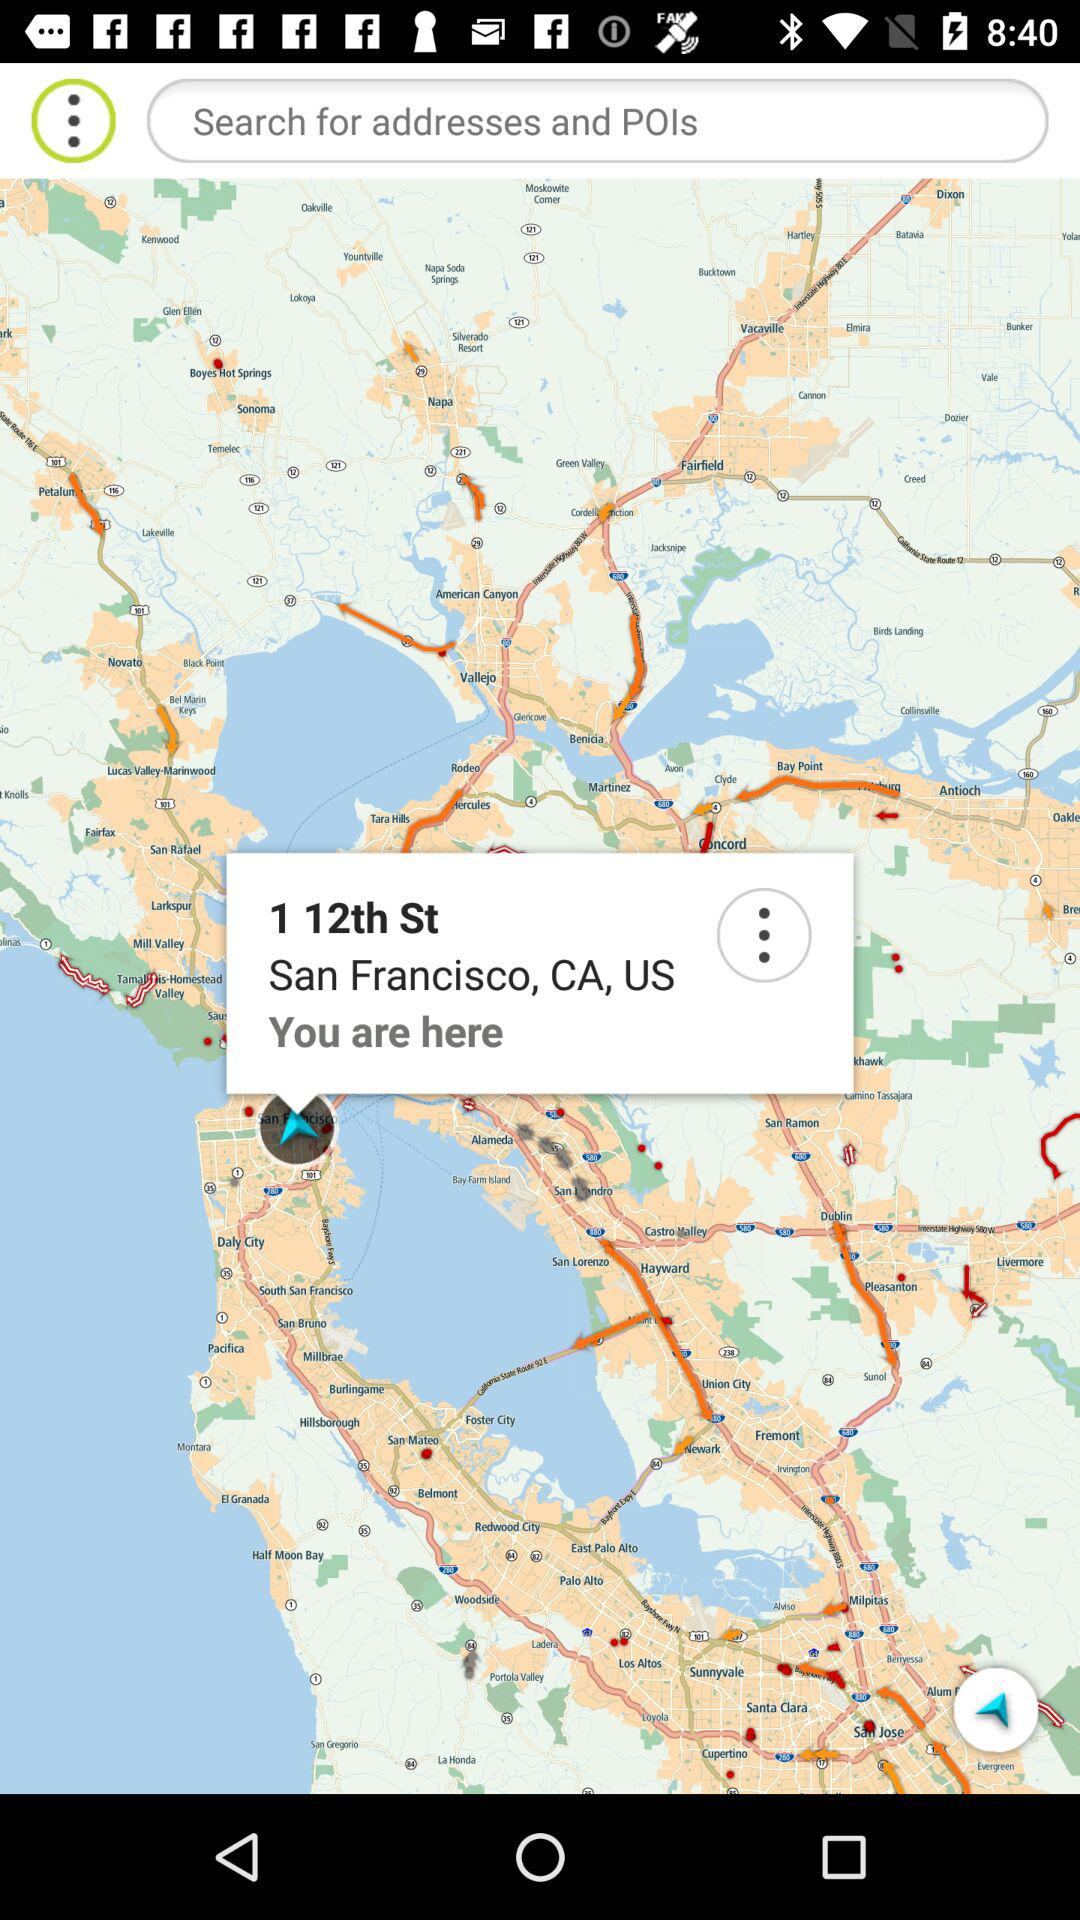What is the current location? The current location is 1 12th St San Francisco, CA, US. 